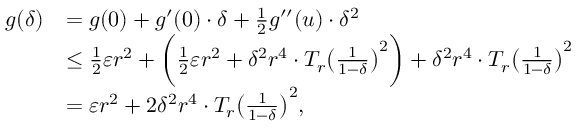<formula> <loc_0><loc_0><loc_500><loc_500>\begin{array} { r l } { g ( \delta ) } & { = g ( 0 ) + g ^ { \prime } ( 0 ) \cdot \delta + \frac { 1 } { 2 } g ^ { \prime \prime } ( u ) \cdot \delta ^ { 2 } } \\ & { \leq \frac { 1 } { 2 } \varepsilon r ^ { 2 } + \left ( \frac { 1 } { 2 } \varepsilon r ^ { 2 } + \delta ^ { 2 } r ^ { 4 } \cdot T _ { r } \left ( \frac { 1 } { 1 - \delta } \right ) ^ { 2 } \right ) + \delta ^ { 2 } r ^ { 4 } \cdot T _ { r } \left ( \frac { 1 } { 1 - \delta } \right ) ^ { 2 } } \\ & { = \varepsilon r ^ { 2 } + 2 \delta ^ { 2 } r ^ { 4 } \cdot T _ { r } \left ( \frac { 1 } { 1 - \delta } \right ) ^ { 2 } , } \end{array}</formula> 